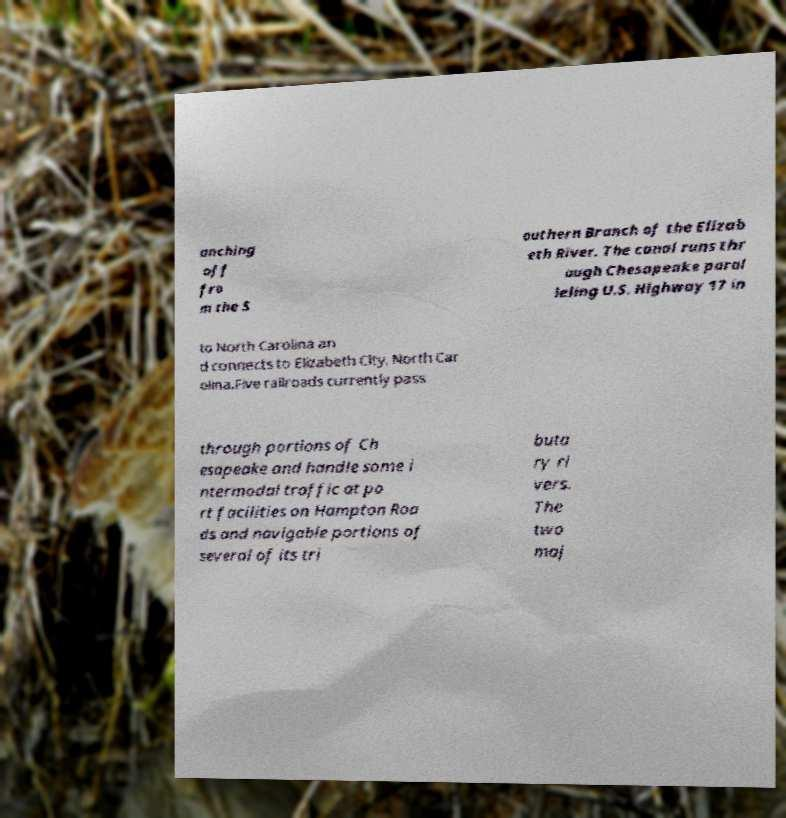Can you read and provide the text displayed in the image?This photo seems to have some interesting text. Can you extract and type it out for me? anching off fro m the S outhern Branch of the Elizab eth River. The canal runs thr ough Chesapeake paral leling U.S. Highway 17 in to North Carolina an d connects to Elizabeth City, North Car olina.Five railroads currently pass through portions of Ch esapeake and handle some i ntermodal traffic at po rt facilities on Hampton Roa ds and navigable portions of several of its tri buta ry ri vers. The two maj 